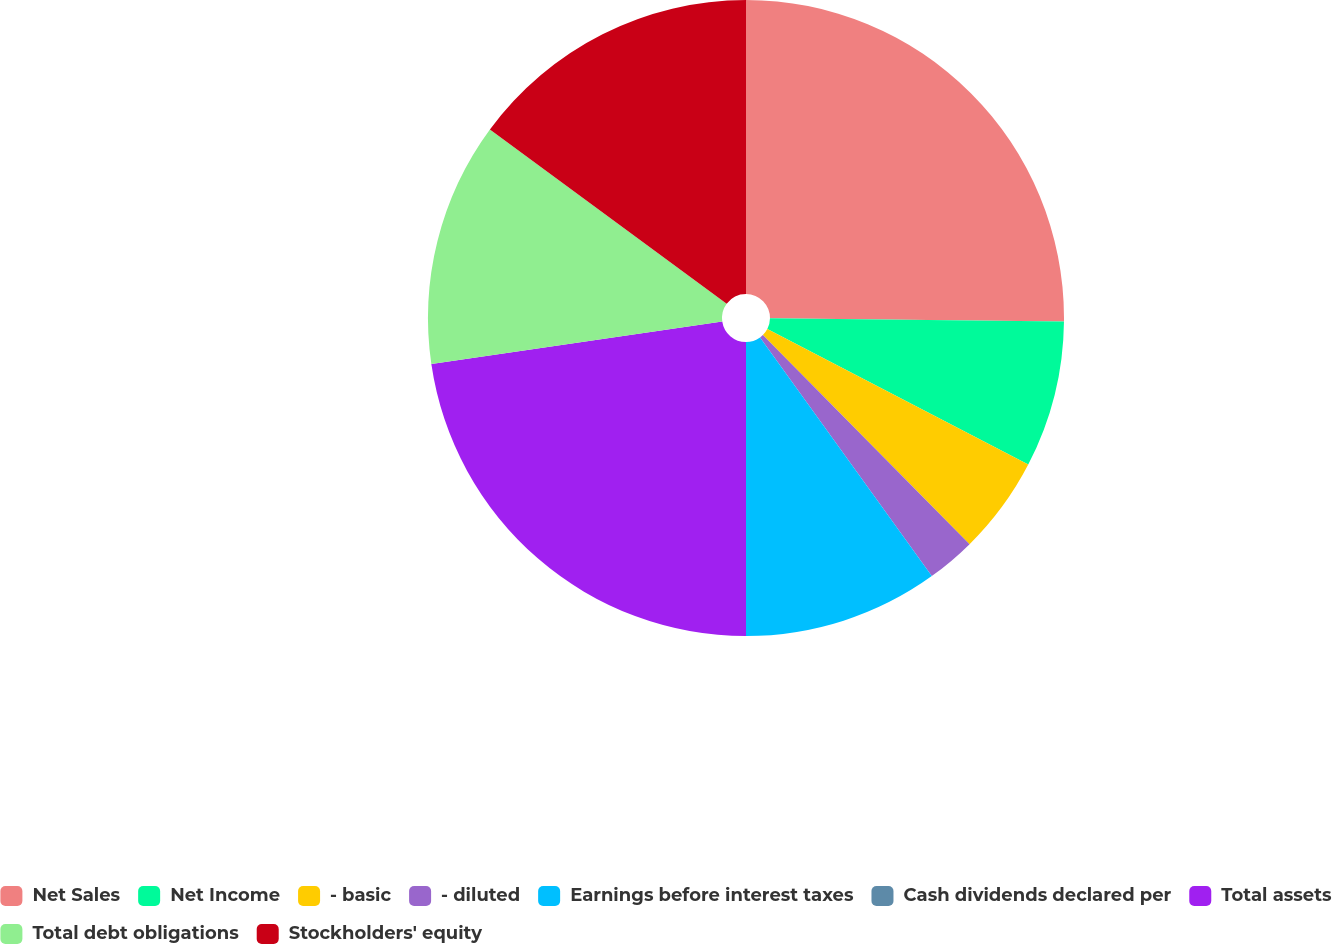Convert chart to OTSL. <chart><loc_0><loc_0><loc_500><loc_500><pie_chart><fcel>Net Sales<fcel>Net Income<fcel>- basic<fcel>- diluted<fcel>Earnings before interest taxes<fcel>Cash dividends declared per<fcel>Total assets<fcel>Total debt obligations<fcel>Stockholders' equity<nl><fcel>25.17%<fcel>7.45%<fcel>4.97%<fcel>2.48%<fcel>9.93%<fcel>0.0%<fcel>22.69%<fcel>12.41%<fcel>14.9%<nl></chart> 